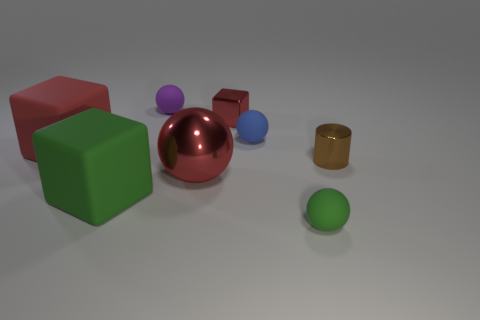Add 1 cyan matte objects. How many objects exist? 9 Subtract all cubes. How many objects are left? 5 Add 4 large green metal balls. How many large green metal balls exist? 4 Subtract 2 red cubes. How many objects are left? 6 Subtract all blue rubber balls. Subtract all spheres. How many objects are left? 3 Add 1 big green rubber things. How many big green rubber things are left? 2 